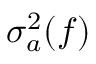Convert formula to latex. <formula><loc_0><loc_0><loc_500><loc_500>\sigma _ { a } ^ { 2 } ( f )</formula> 